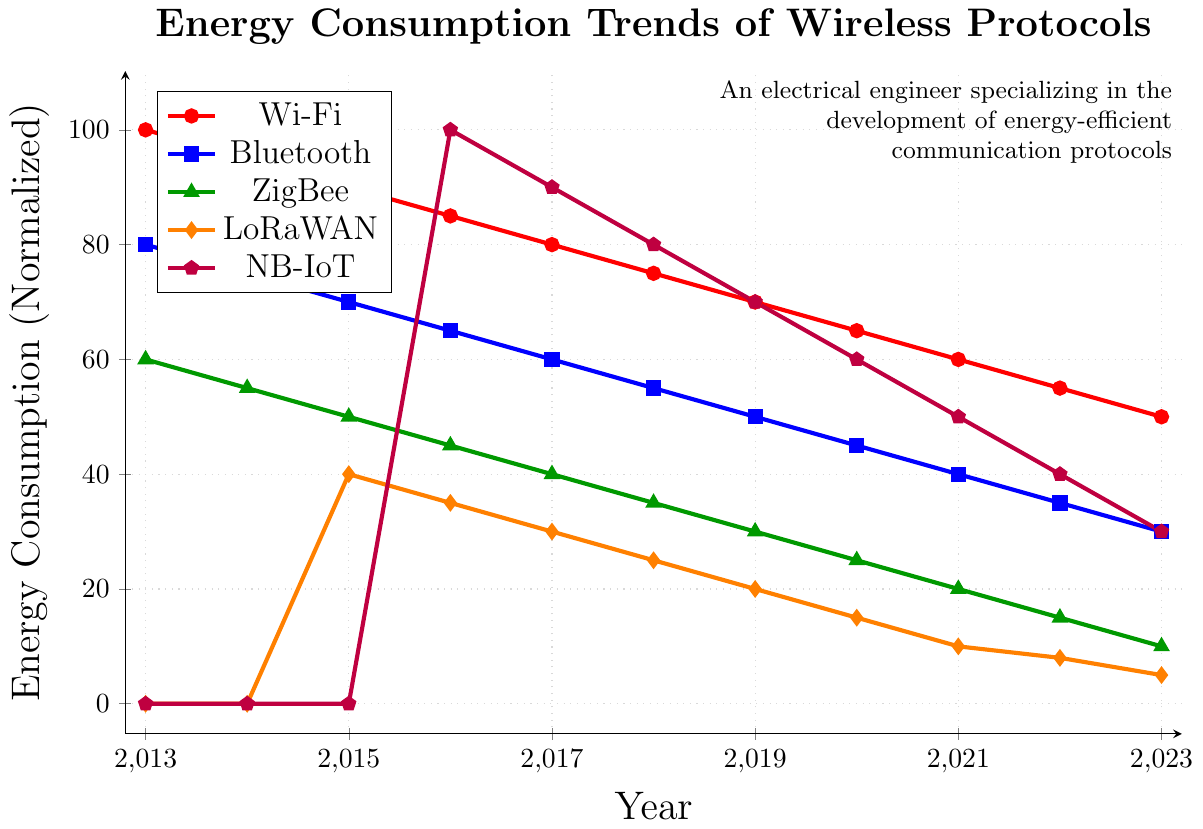How has the energy consumption of Wi-Fi changed from 2013 to 2023? Looking at the red line representing Wi-Fi, it starts at 100 in 2013 and ends at 50 in 2023, showing a decrease.
Answer: Decreased by 50 Compare the rate of decrease in energy consumption between Bluetooth and ZigBee from 2013 to 2023. The blue line (Bluetooth) decreases from 80 to 30 (a difference of 50 units), while the green line (ZigBee) decreases from 60 to 10 (a difference of 50 units). Both have decreased by the same amount.
Answer: Same rate of decrease Which protocol had the highest energy consumption in 2016? In 2016, we look at the values for all protocols and notice that NB-IoT (purple line) is at 100, which is the highest among all.
Answer: NB-IoT What is the sum of energy consumption values for LoRaWAN in the years 2018 and 2020? From the orange line, the energy consumption for LoRaWAN in 2018 is 25 and in 2020 it's 15. Adding these values, 25 + 15 = 40.
Answer: 40 Determine the average energy consumption for Bluetooth from 2013 to 2018. Looking at the blue line, the values from 2013 to 2018 are 80, 75, 70, 65, 60, and 55. The sum is 405, and there are 6 values. The average is 405/6 ≈ 67.5.
Answer: 67.5 Which protocol shows the least variation in energy consumption over the decade? The graph shows that NB-IoT and LoRaWAN have significant variations, while Wi-Fi, Bluetooth, and ZigBee have steady, gradual decreases. ZigBee shows a regular and less steep decrease, indicating the least variation.
Answer: ZigBee In which years did no protocols have a normalized energy consumption of exactly 50? Analyzing the figure, in years where any protocol hits the 50 marker—the only such case is NB-IoT in 2021. No other year shares exact markers of 50.
Answer: All years except 2021 What is the combined energy consumption of all protocols in the year 2020? Summing the values: Wi-Fi (65), Bluetooth (45), ZigBee (25), LoRaWAN (15), NB-IoT (60). Total = 65 + 45 + 25 + 15 + 60 = 210.
Answer: 210 What is the average decrease in energy consumption per year for Wi-Fi from 2013 to 2023? The decline for Wi-Fi is from 100 in 2013 to 50 in 2023. This decline is 50 units over 10 years. The average decrease per year is 50 / 10 = 5 units per year.
Answer: 5 units per year 